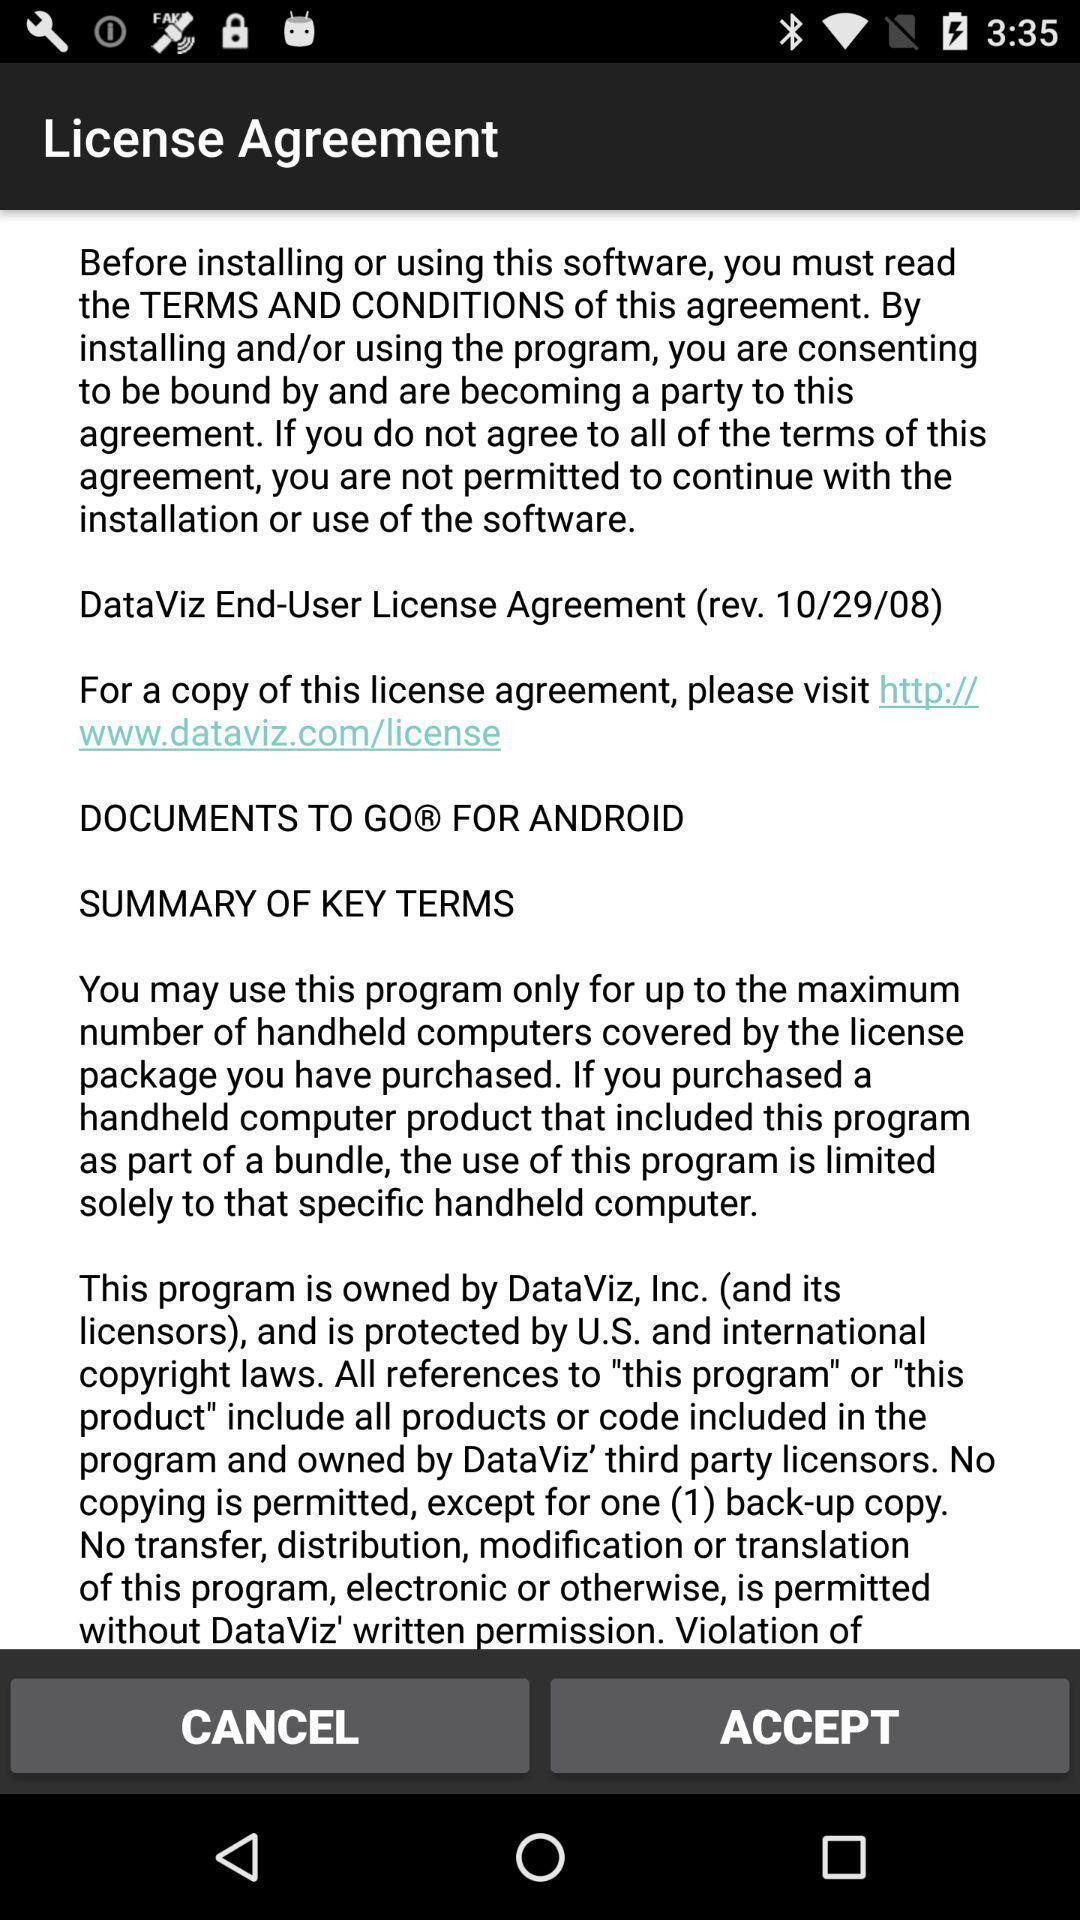Give me a summary of this screen capture. Page that displaying accept the license agreement. 